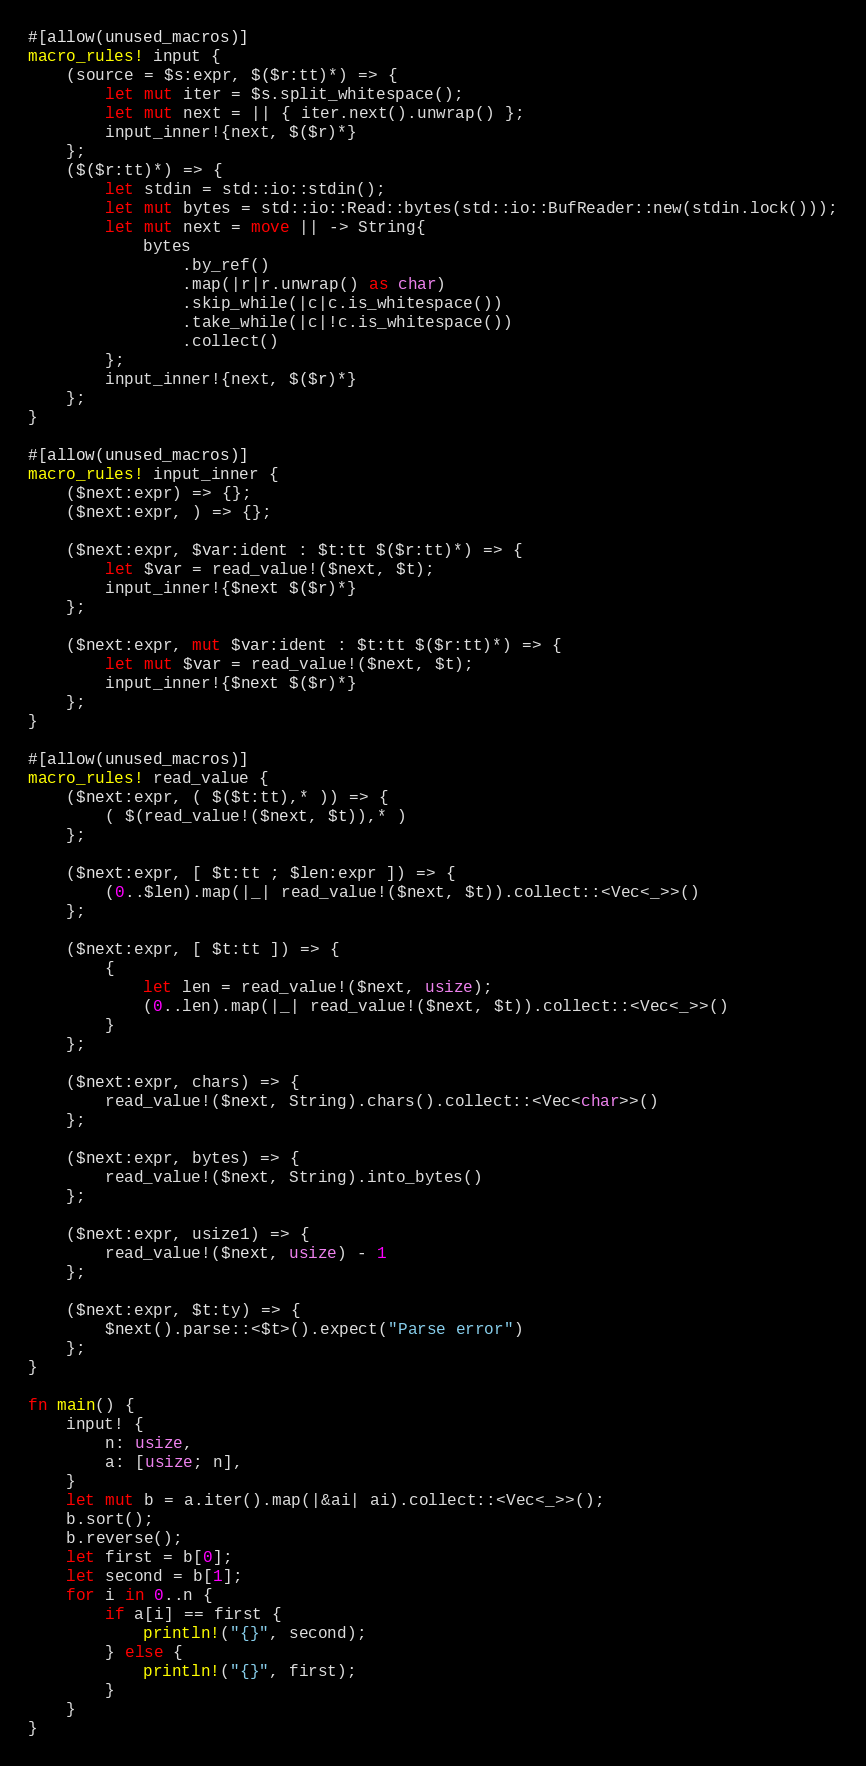<code> <loc_0><loc_0><loc_500><loc_500><_Rust_>#[allow(unused_macros)]
macro_rules! input {
    (source = $s:expr, $($r:tt)*) => {
        let mut iter = $s.split_whitespace();
        let mut next = || { iter.next().unwrap() };
        input_inner!{next, $($r)*}
    };
    ($($r:tt)*) => {
        let stdin = std::io::stdin();
        let mut bytes = std::io::Read::bytes(std::io::BufReader::new(stdin.lock()));
        let mut next = move || -> String{
            bytes
                .by_ref()
                .map(|r|r.unwrap() as char)
                .skip_while(|c|c.is_whitespace())
                .take_while(|c|!c.is_whitespace())
                .collect()
        };
        input_inner!{next, $($r)*}
    };
}

#[allow(unused_macros)]
macro_rules! input_inner {
    ($next:expr) => {};
    ($next:expr, ) => {};

    ($next:expr, $var:ident : $t:tt $($r:tt)*) => {
        let $var = read_value!($next, $t);
        input_inner!{$next $($r)*}
    };

    ($next:expr, mut $var:ident : $t:tt $($r:tt)*) => {
        let mut $var = read_value!($next, $t);
        input_inner!{$next $($r)*}
    };
}

#[allow(unused_macros)]
macro_rules! read_value {
    ($next:expr, ( $($t:tt),* )) => {
        ( $(read_value!($next, $t)),* )
    };

    ($next:expr, [ $t:tt ; $len:expr ]) => {
        (0..$len).map(|_| read_value!($next, $t)).collect::<Vec<_>>()
    };

    ($next:expr, [ $t:tt ]) => {
        {
            let len = read_value!($next, usize);
            (0..len).map(|_| read_value!($next, $t)).collect::<Vec<_>>()
        }
    };

    ($next:expr, chars) => {
        read_value!($next, String).chars().collect::<Vec<char>>()
    };

    ($next:expr, bytes) => {
        read_value!($next, String).into_bytes()
    };

    ($next:expr, usize1) => {
        read_value!($next, usize) - 1
    };

    ($next:expr, $t:ty) => {
        $next().parse::<$t>().expect("Parse error")
    };
}

fn main() {
    input! {
        n: usize,
        a: [usize; n],
    }
    let mut b = a.iter().map(|&ai| ai).collect::<Vec<_>>();
    b.sort();
    b.reverse();
    let first = b[0];
    let second = b[1];
    for i in 0..n {
        if a[i] == first {
            println!("{}", second);
        } else {
            println!("{}", first);
        }
    }
}
</code> 